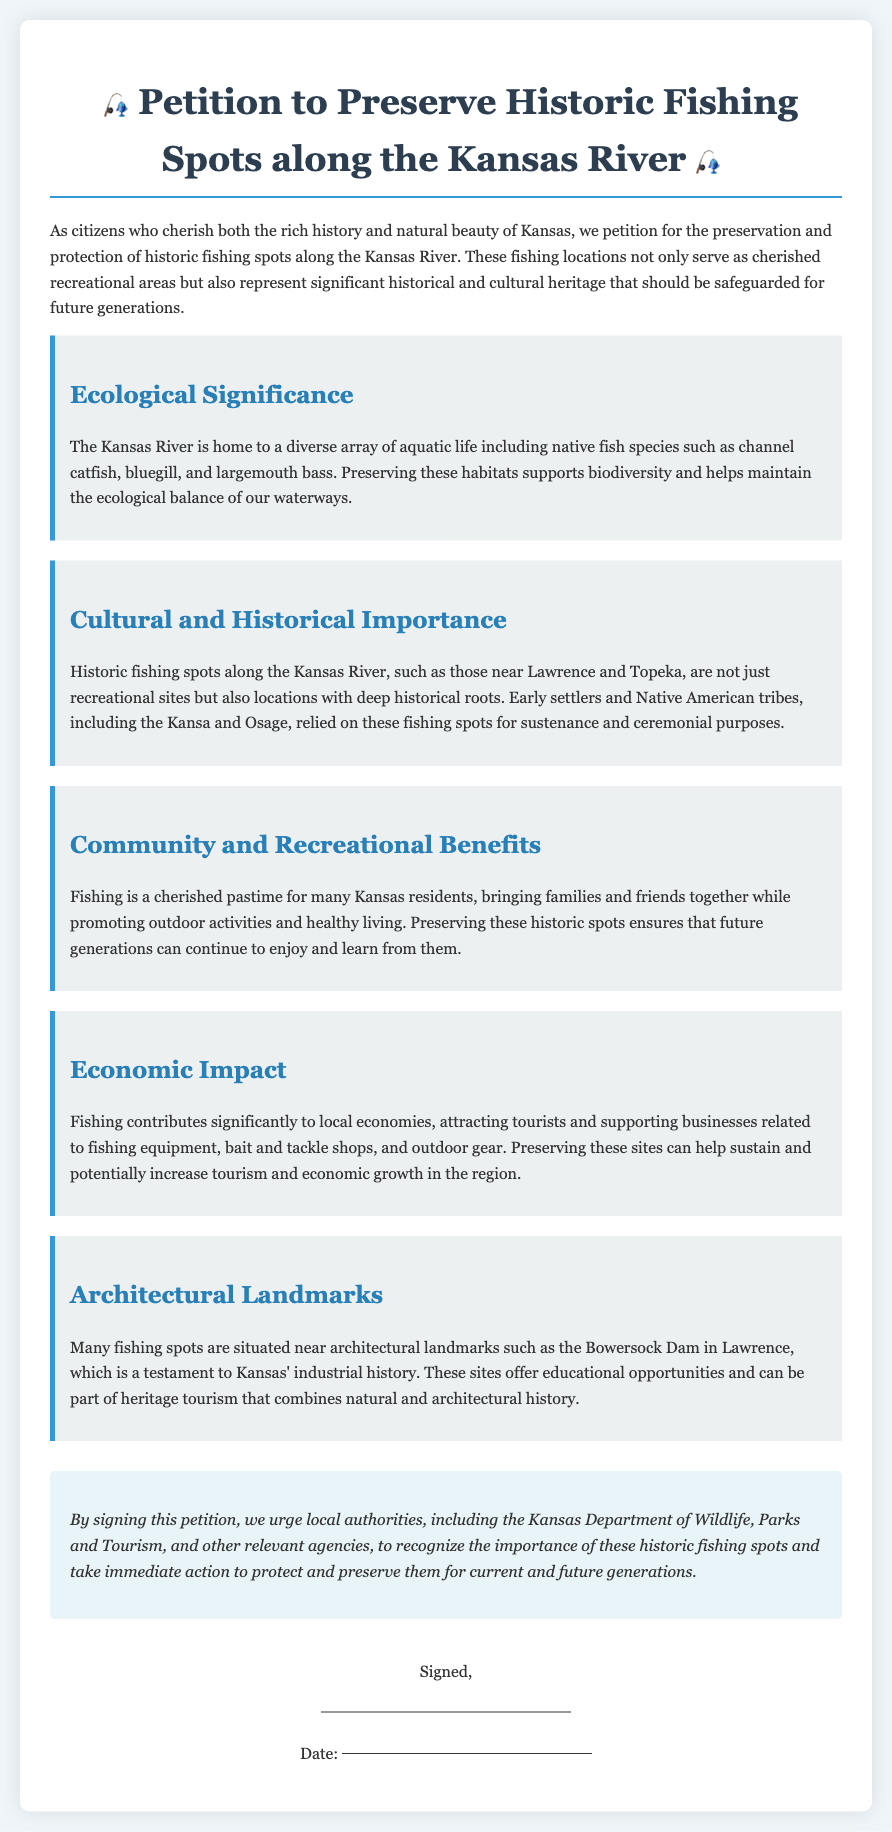What is the title of the petition? The title of the petition is presented prominently at the top of the document in the header format.
Answer: Petition to Preserve Historic Fishing Spots along the Kansas River What are the key points discussed in the petition? The petition outlines various key points categorized under headings indicating different aspects of preservation, including ecological significance, cultural importance, and economic impact.
Answer: Ecological Significance, Cultural and Historical Importance, Community and Recreational Benefits, Economic Impact, Architectural Landmarks Which native fish species are mentioned? The document lists specific fish species to highlight the biodiversity supported by the Kansas River ecosystem.
Answer: channel catfish, bluegill, and largemouth bass What historical communities are referenced in the petition? The petition acknowledges the contributions of early settlers and specific Native American tribes that historically relied on the fishing spots.
Answer: Kansa and Osage What is one economic benefit of preserving fishing spots mentioned? The document discusses how fishing can contribute to local economies and tourism, thereby supporting related businesses.
Answer: attracting tourists What architectural landmark is specifically mentioned in relation to fishing spots? The petition includes a landmark that is relevant both to the area's fishing history and its industrial significance in Kansas.
Answer: Bowersock Dam What is the conclusion of the petition? The petition concludes with a call to action urging local authorities to recognize and act on the importance of preservation.
Answer: take immediate action to protect and preserve them How does fishing impact community activities according to the petition? The petition highlights fishing as a recreational activity that fosters togetherness among residents, emphasizing its role in promoting outdoor activities.
Answer: brings families and friends together 